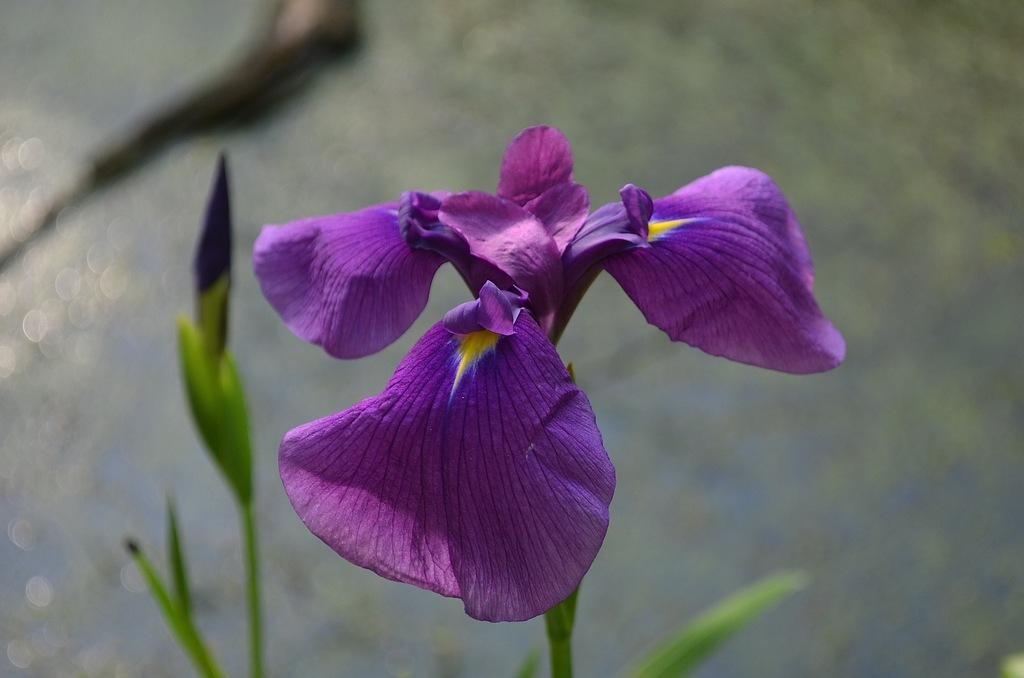Please provide a concise description of this image. In this picture I can see a plant with a flower and a bud, and there is blur background. 